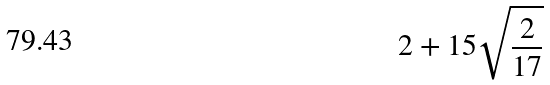<formula> <loc_0><loc_0><loc_500><loc_500>2 + 1 5 \sqrt { \frac { 2 } { 1 7 } }</formula> 